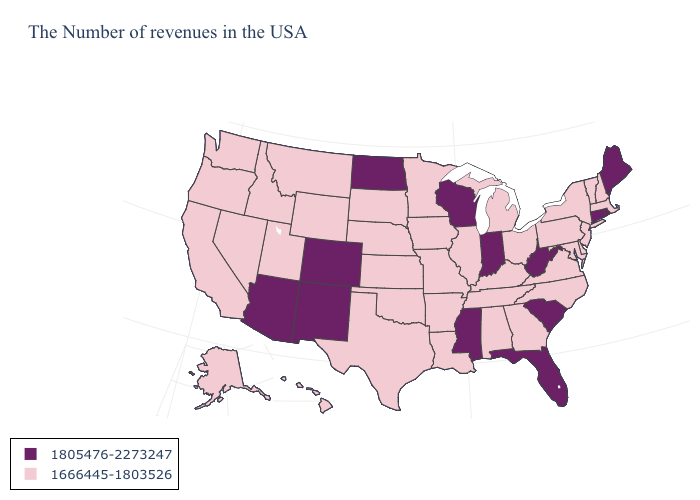Name the states that have a value in the range 1666445-1803526?
Answer briefly. Massachusetts, New Hampshire, Vermont, New York, New Jersey, Delaware, Maryland, Pennsylvania, Virginia, North Carolina, Ohio, Georgia, Michigan, Kentucky, Alabama, Tennessee, Illinois, Louisiana, Missouri, Arkansas, Minnesota, Iowa, Kansas, Nebraska, Oklahoma, Texas, South Dakota, Wyoming, Utah, Montana, Idaho, Nevada, California, Washington, Oregon, Alaska, Hawaii. What is the value of Arkansas?
Quick response, please. 1666445-1803526. Which states hav the highest value in the South?
Short answer required. South Carolina, West Virginia, Florida, Mississippi. Does Indiana have the same value as Florida?
Be succinct. Yes. What is the value of Texas?
Give a very brief answer. 1666445-1803526. What is the value of Wyoming?
Concise answer only. 1666445-1803526. Does New Hampshire have the highest value in the USA?
Write a very short answer. No. Which states hav the highest value in the MidWest?
Be succinct. Indiana, Wisconsin, North Dakota. Is the legend a continuous bar?
Short answer required. No. Does Idaho have the highest value in the USA?
Keep it brief. No. What is the value of Florida?
Be succinct. 1805476-2273247. Name the states that have a value in the range 1666445-1803526?
Keep it brief. Massachusetts, New Hampshire, Vermont, New York, New Jersey, Delaware, Maryland, Pennsylvania, Virginia, North Carolina, Ohio, Georgia, Michigan, Kentucky, Alabama, Tennessee, Illinois, Louisiana, Missouri, Arkansas, Minnesota, Iowa, Kansas, Nebraska, Oklahoma, Texas, South Dakota, Wyoming, Utah, Montana, Idaho, Nevada, California, Washington, Oregon, Alaska, Hawaii. What is the value of New York?
Concise answer only. 1666445-1803526. Which states have the lowest value in the MidWest?
Keep it brief. Ohio, Michigan, Illinois, Missouri, Minnesota, Iowa, Kansas, Nebraska, South Dakota. How many symbols are there in the legend?
Short answer required. 2. 